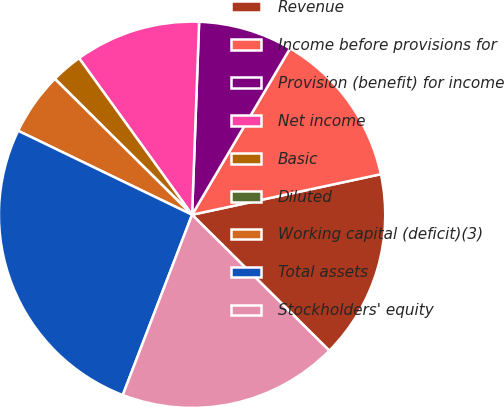<chart> <loc_0><loc_0><loc_500><loc_500><pie_chart><fcel>Revenue<fcel>Income before provisions for<fcel>Provision (benefit) for income<fcel>Net income<fcel>Basic<fcel>Diluted<fcel>Working capital (deficit)(3)<fcel>Total assets<fcel>Stockholders' equity<nl><fcel>15.79%<fcel>13.16%<fcel>7.89%<fcel>10.53%<fcel>2.63%<fcel>0.0%<fcel>5.26%<fcel>26.32%<fcel>18.42%<nl></chart> 